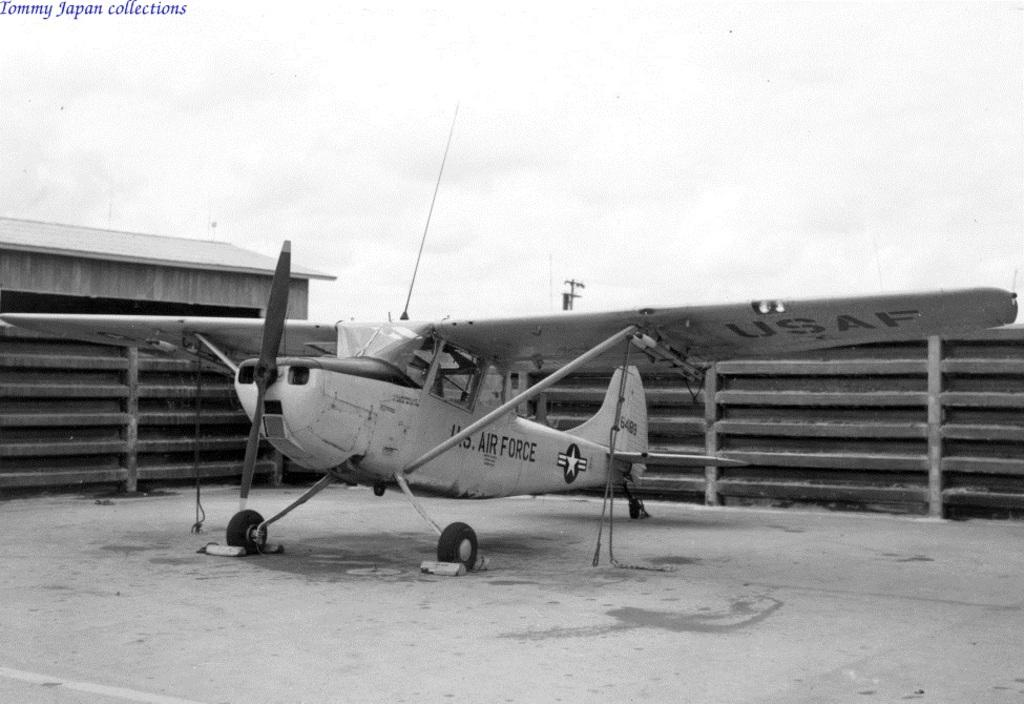<image>
Provide a brief description of the given image. Small plane with the words AIR FORCE on the side parked in a parking lot. 